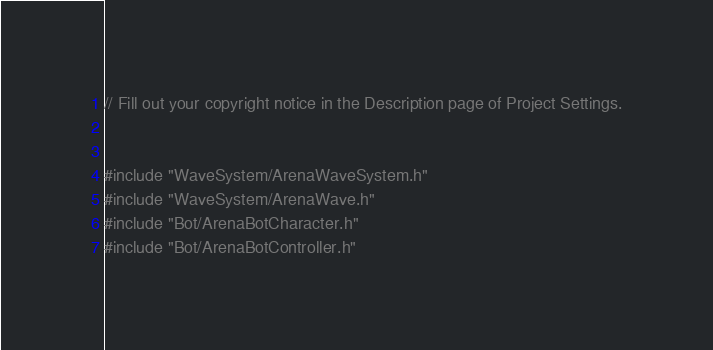<code> <loc_0><loc_0><loc_500><loc_500><_C++_>// Fill out your copyright notice in the Description page of Project Settings.


#include "WaveSystem/ArenaWaveSystem.h"
#include "WaveSystem/ArenaWave.h"
#include "Bot/ArenaBotCharacter.h"
#include "Bot/ArenaBotController.h"</code> 